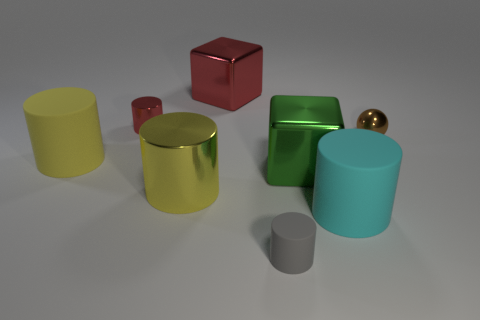There is a block that is the same color as the tiny metallic cylinder; what material is it?
Provide a short and direct response. Metal. How many things are either big cubes behind the tiny red metallic thing or matte cylinders on the right side of the big yellow metal thing?
Make the answer very short. 3. Are there more yellow things that are right of the yellow metal cylinder than shiny objects?
Make the answer very short. No. What number of other objects are the same shape as the cyan matte thing?
Ensure brevity in your answer.  4. There is a object that is on the right side of the small matte object and behind the large green object; what is it made of?
Make the answer very short. Metal. How many things are small gray cylinders or cyan rubber objects?
Ensure brevity in your answer.  2. Is the number of brown balls greater than the number of yellow spheres?
Offer a terse response. Yes. What size is the cylinder behind the small metallic thing that is to the right of the gray thing?
Offer a very short reply. Small. There is a big shiny object that is the same shape as the cyan matte thing; what color is it?
Give a very brief answer. Yellow. The brown metal thing has what size?
Ensure brevity in your answer.  Small. 